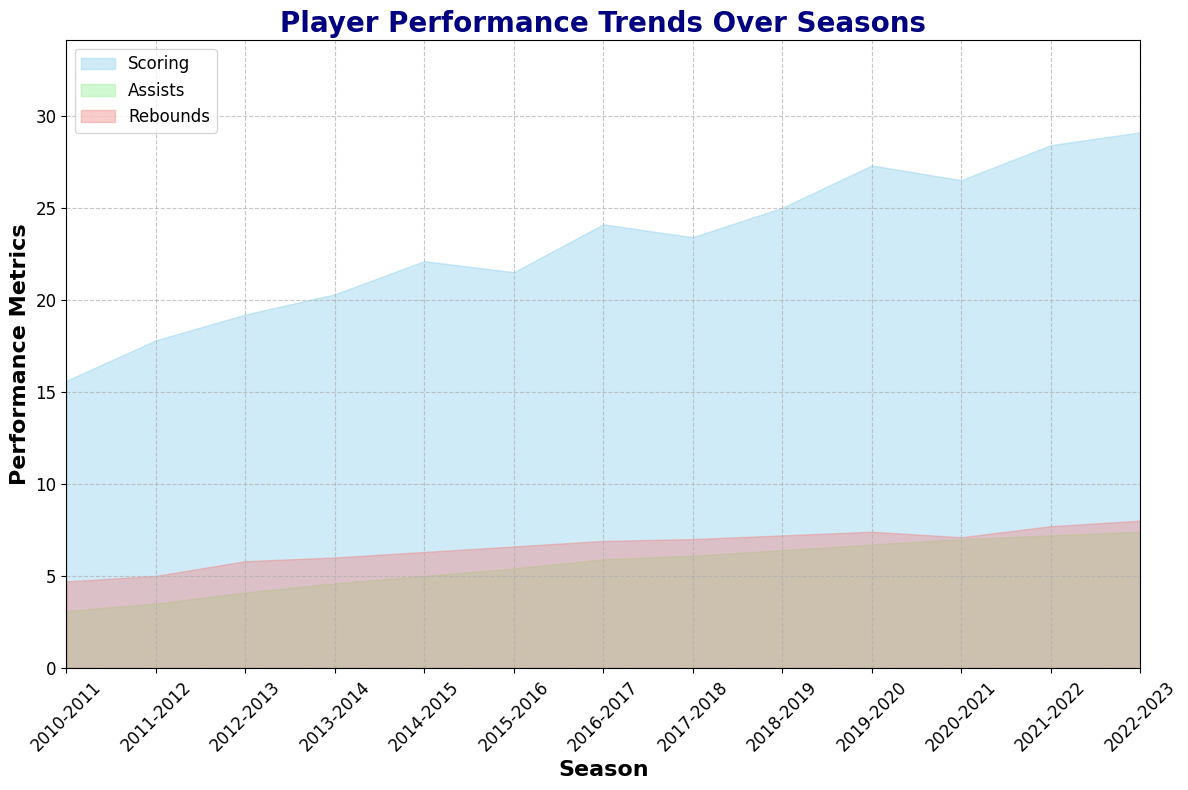What's the range of scoring performance over the seasons? To find the range, subtract the lowest scoring performance from the highest scoring performance. The minimum score is 15.6 (2010-2011) and the maximum score is 29.1 (2022-2023). Therefore, the range is 29.1 - 15.6 = 13.5.
Answer: 13.5 How did the player's assists change from the 2015-2016 to the 2020-2021 season? Look at the assists values for the 2015-2016 and 2020-2021 seasons. In 2015-2016, assists were 5.4, and in 2020-2021, assists were 7.0. The change in assists is 7.0 - 5.4 = 1.6.
Answer: 1.6 Which season experienced the highest rebounds? Look for the maximum value in the rebounding data series. The highest rebounds value is 8.0 in the 2022-2023 season.
Answer: 2022-2023 Compare the assist performance between the seasons 2013-2014 and 2019-2020. Which season had a better performance? Look at the assist values for these seasons. In 2013-2014, assists were 4.6, and in 2019-2020, assists were 6.7. Therefore, 2019-2020 had a better performance in assists.
Answer: 2019-2020 How do scoring trends compare to assists trends over the seasons? Scoring and assists both generally increase over the seasons, but the scoring increases at a steeper rate. The scoring starts at 15.6 and ends at 29.1, whereas assists start at 3.1 and end at 7.4.
Answer: Both are trending upward, with scoring increasing more steeply During which season did the player have the largest improvement in scoring compared to the previous season? Calculate the year-on-year change in scoring and find the maximum increase. The largest improvement is between 2018-2019 (25.0) and 2019-2020 (27.3); therefore, the improvement is 27.3 - 25.0 = 2.3.
Answer: 2019-2020 What visual attribute helps distinguish the scoring area from assists? The color of the areas helps distinguish them: scoring is shown in sky blue, while assists are shown in light green.
Answer: Color Calculate the average scoring over all the seasons. Sum all the scoring values and divide by the number of seasons. The sum is (15.6 + 17.8 + 19.2 + 20.3 + 22.1 + 21.5 + 24.1 + 23.4 + 25.0 + 27.3 + 26.5 + 28.4 + 29.1). The number of seasons is 13. The average is 300.3 / 13 = 23.1 (approx).
Answer: 23.1 